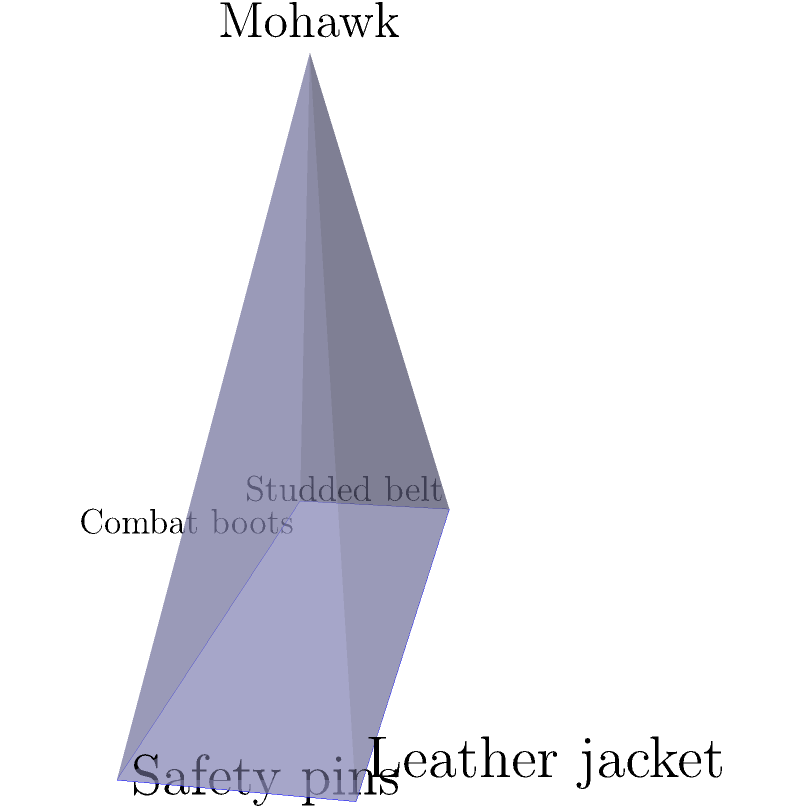Consider the evolution of punk rock fashion trends represented by the polyhedron above. If we introduce two new fashion elements by adding two vertices and connecting them to all existing vertices, how many new edges will be created in total? Express your answer in terms of the original number of vertices, $v$. Let's approach this step-by-step:

1) First, we need to identify the number of vertices in the original polyhedron. From the diagram, we can see that there are 5 vertices (v = 5).

2) When we add a new vertex and connect it to all existing vertices, the number of new edges created is equal to the number of existing vertices.

3) We are adding two new vertices, so we need to do this process twice.

4) For the first new vertex:
   - Number of new edges = v

5) For the second new vertex:
   - It needs to connect to all original vertices (v) and also to the other new vertex.
   - Number of new edges = v + 1

6) Total number of new edges:
   $$(v) + (v + 1) = 2v + 1$$

7) We need to express this in terms of the original number of vertices, which is already v.

Therefore, the total number of new edges created is $2v + 1$.
Answer: $2v + 1$ 